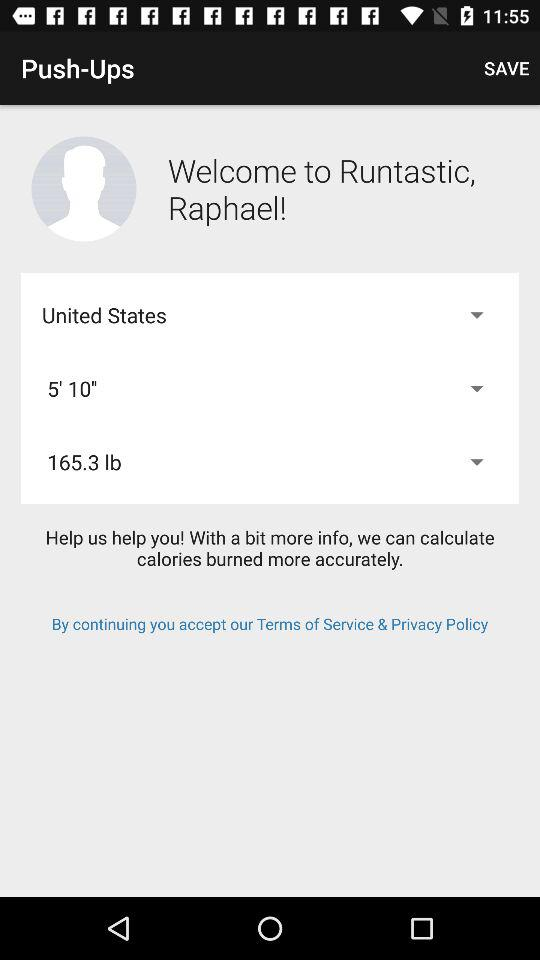What is the app name? The app name is "Runtastic". 